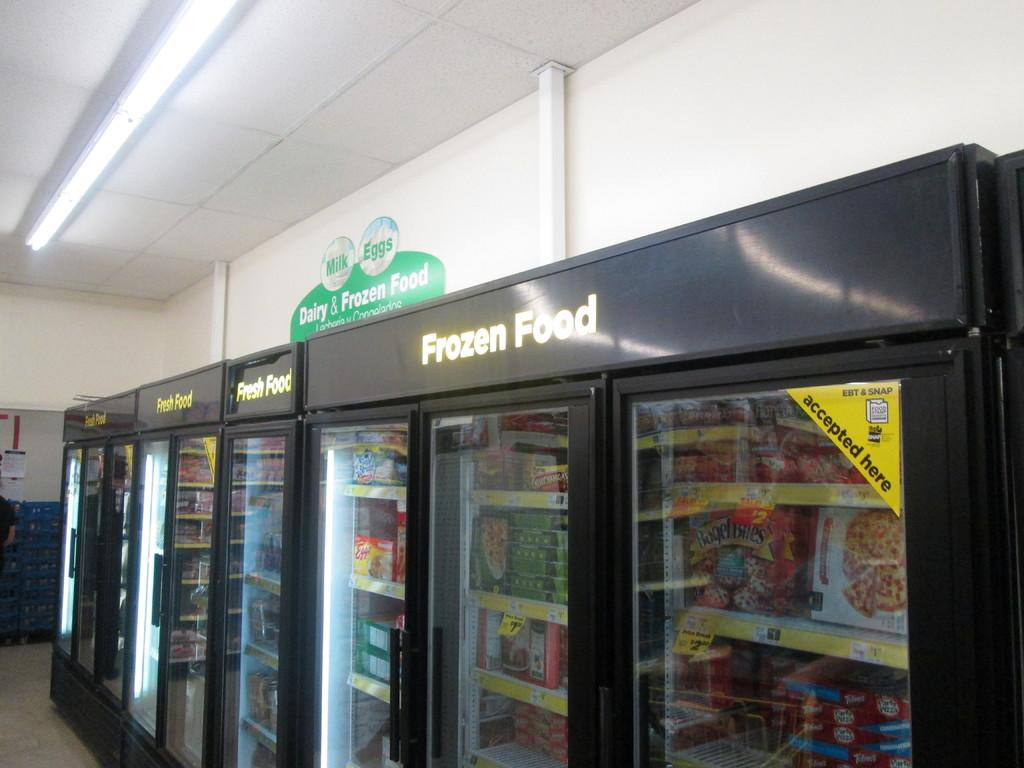<image>
Render a clear and concise summary of the photo. 3 larg black freezers under a green Dairy & Frozen Food labelled Frozen Food. 